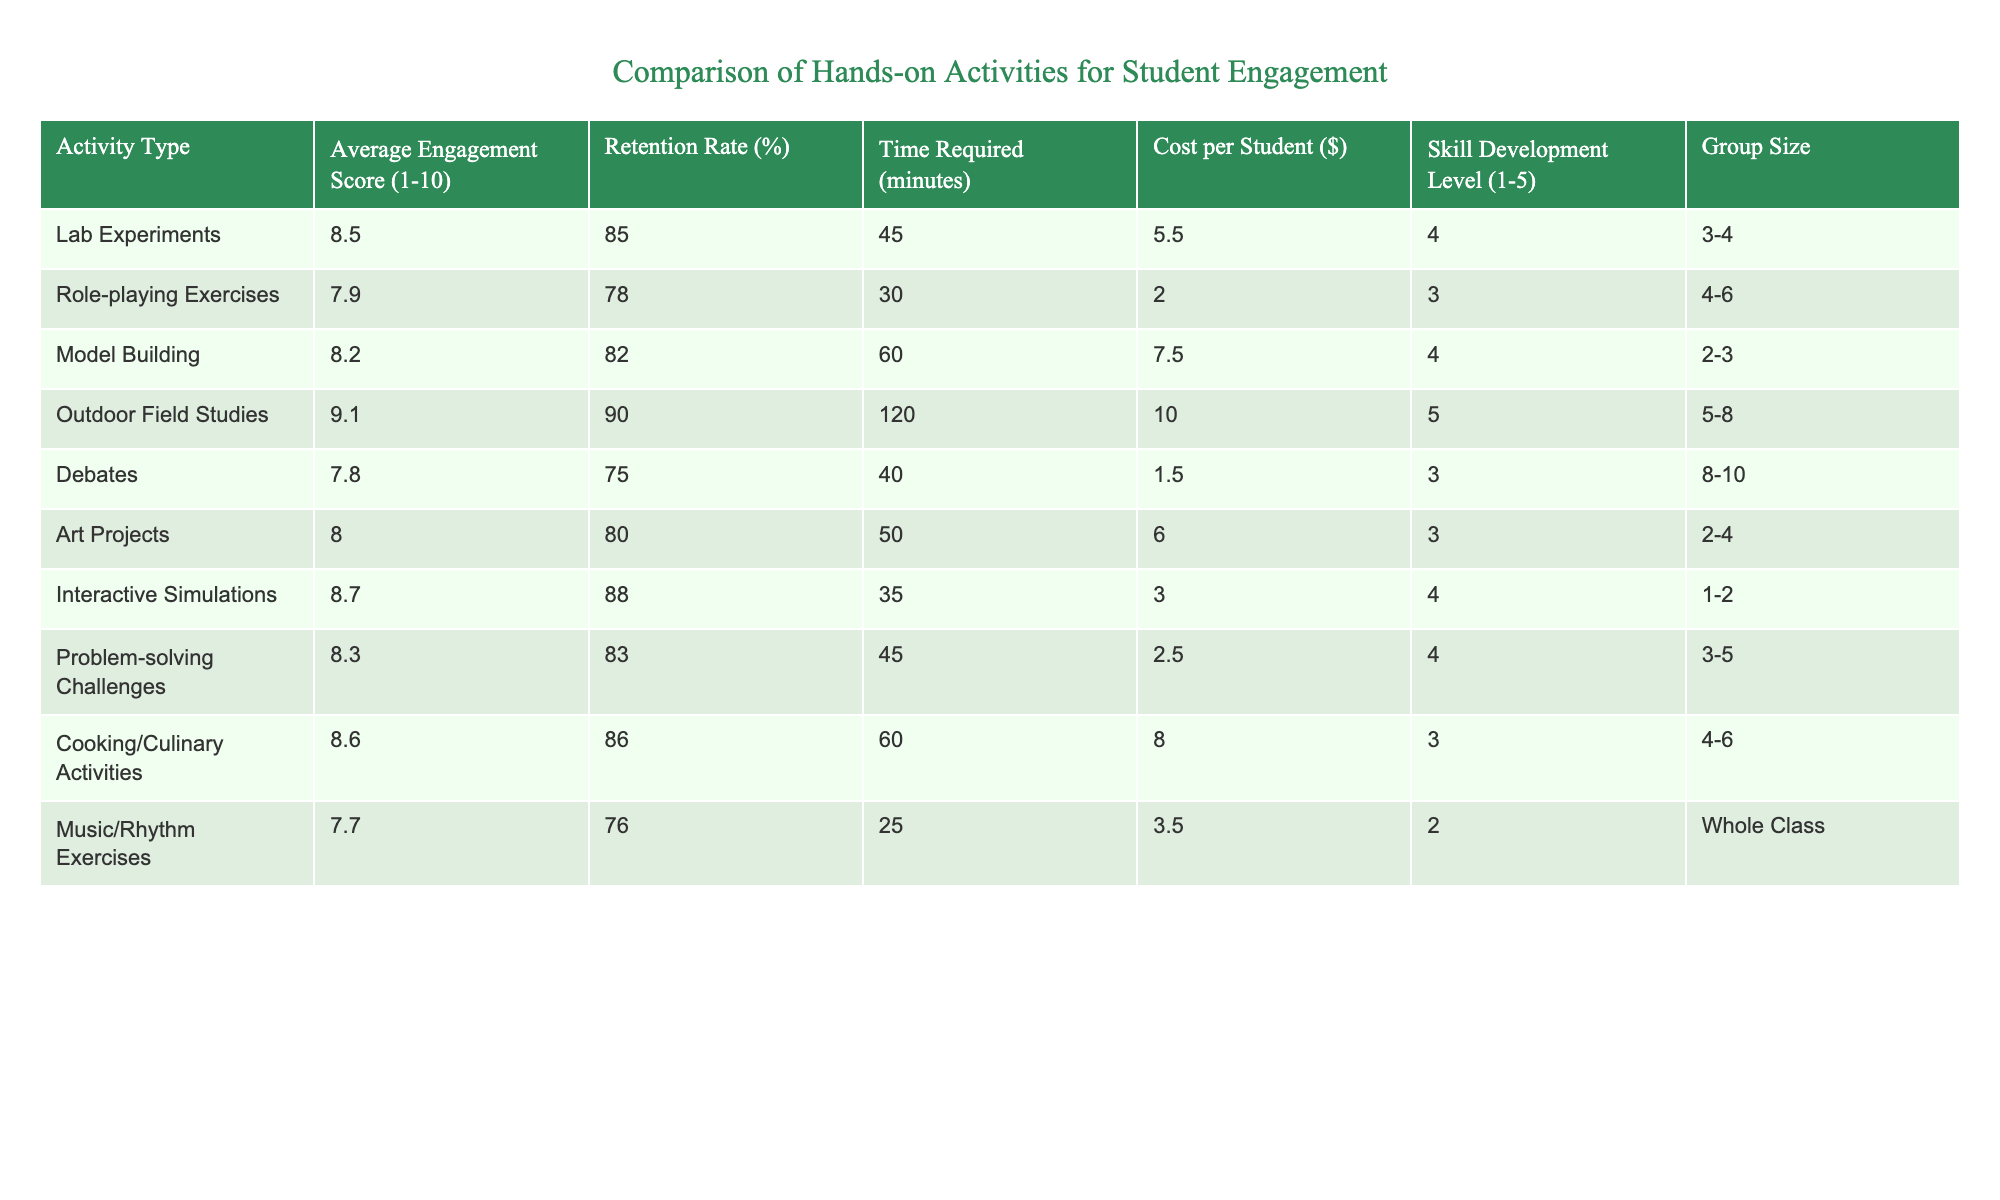What is the average engagement score for Outdoor Field Studies? According to the table, the average engagement score for Outdoor Field Studies is directly provided in the "Average Engagement Score" column, which indicates a score of 9.1.
Answer: 9.1 Which activity type has the highest retention rate? By reviewing the "Retention Rate" column, the highest retention rate is associated with Outdoor Field Studies, which has a rate of 90%.
Answer: 90% What is the total time required for Lab Experiments and Problem-solving Challenges combined? The total time required for Lab Experiments is 45 minutes, and for Problem-solving Challenges, it is also 45 minutes. Combining these gives a total time of 45 + 45 = 90 minutes.
Answer: 90 minutes Is the average engagement score for Cooking/Culinary Activities higher than that for Role-playing Exercises? The average engagement score for Cooking/Culinary Activities is 8.6, whereas that for Role-playing Exercises is 7.9. Since 8.6 is greater than 7.9, the statement holds true.
Answer: Yes What is the average cost per student for the top three activities based on engagement score? The top three activities based on engagement score are: Outdoor Field Studies (10.00), Interactive Simulations (3.00), and Lab Experiments (5.50). The average cost per student is (10.00 + 3.00 + 5.50) / 3 = 6.17.
Answer: 6.17 Does the group size for Art Projects exceed that for Music/Rhythm Exercises? The group size for Art Projects is 2-4, while Music/Rhythm Exercises is specified as the whole class. Since "whole class" suggests a larger group, the statement is false.
Answer: No What is the difference in average engagement score between the least and most engaging activities? The least engaging activity is Music/Rhythm Exercises with a score of 7.7, and the most engaging activity is Outdoor Field Studies with a score of 9.1. The difference is 9.1 - 7.7 = 1.4.
Answer: 1.4 How many activities have a skill development level of 4 or higher? By examining the "Skill Development Level" column, the activities Lab Experiments, Outdoor Field Studies, Interactive Simulations, and Cooking/Culinary Activities have levels of 4 or 5. Thus, there are four activities that meet this criterion.
Answer: 4 